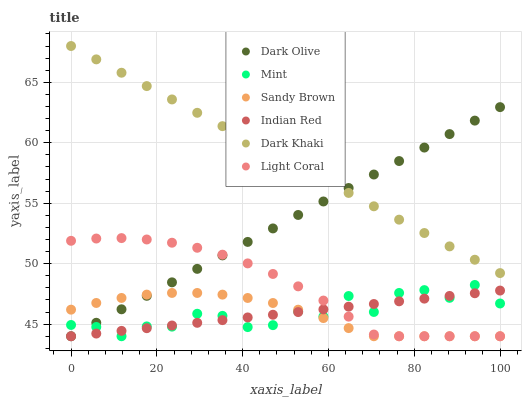Does Sandy Brown have the minimum area under the curve?
Answer yes or no. Yes. Does Dark Khaki have the maximum area under the curve?
Answer yes or no. Yes. Does Mint have the minimum area under the curve?
Answer yes or no. No. Does Mint have the maximum area under the curve?
Answer yes or no. No. Is Indian Red the smoothest?
Answer yes or no. Yes. Is Mint the roughest?
Answer yes or no. Yes. Is Dark Olive the smoothest?
Answer yes or no. No. Is Dark Olive the roughest?
Answer yes or no. No. Does Light Coral have the lowest value?
Answer yes or no. Yes. Does Dark Khaki have the lowest value?
Answer yes or no. No. Does Dark Khaki have the highest value?
Answer yes or no. Yes. Does Mint have the highest value?
Answer yes or no. No. Is Indian Red less than Dark Khaki?
Answer yes or no. Yes. Is Dark Khaki greater than Light Coral?
Answer yes or no. Yes. Does Indian Red intersect Light Coral?
Answer yes or no. Yes. Is Indian Red less than Light Coral?
Answer yes or no. No. Is Indian Red greater than Light Coral?
Answer yes or no. No. Does Indian Red intersect Dark Khaki?
Answer yes or no. No. 